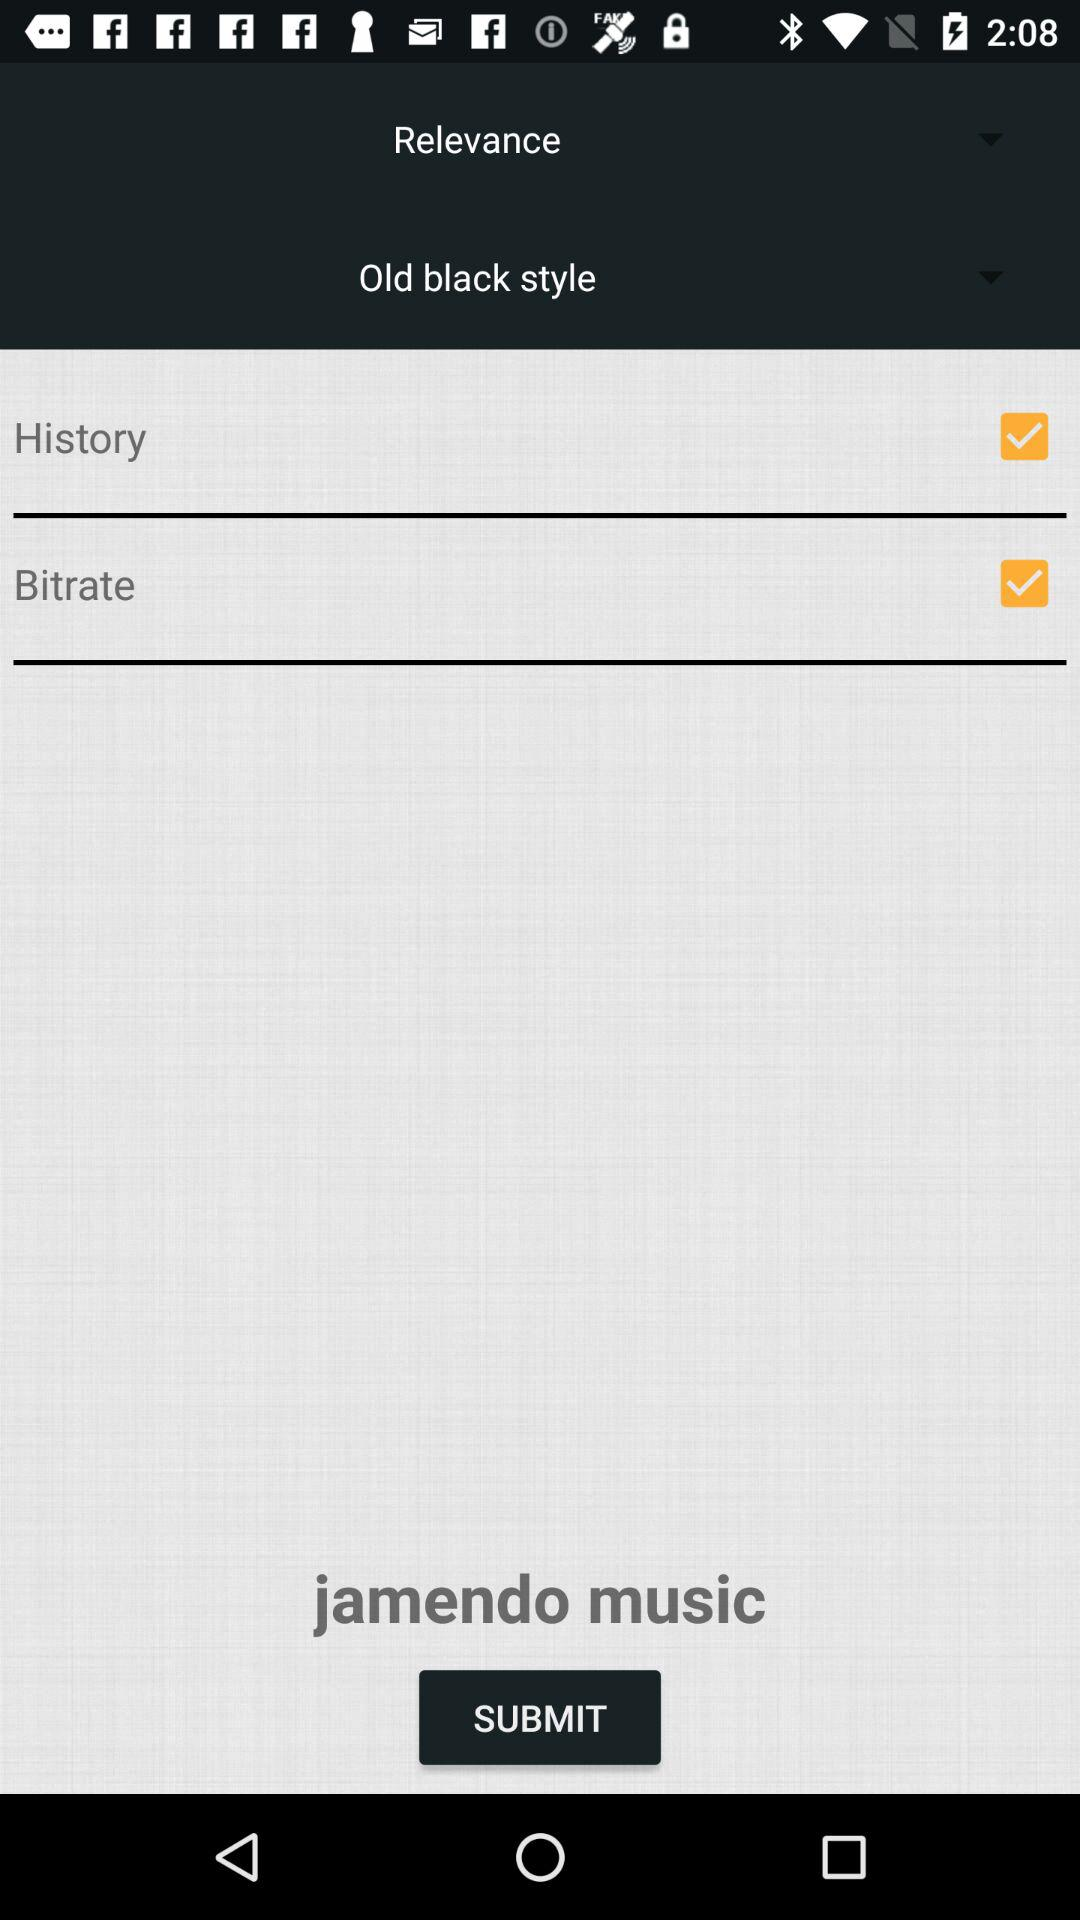Which option was selected? The selected options were "History" and "Bitrate". 